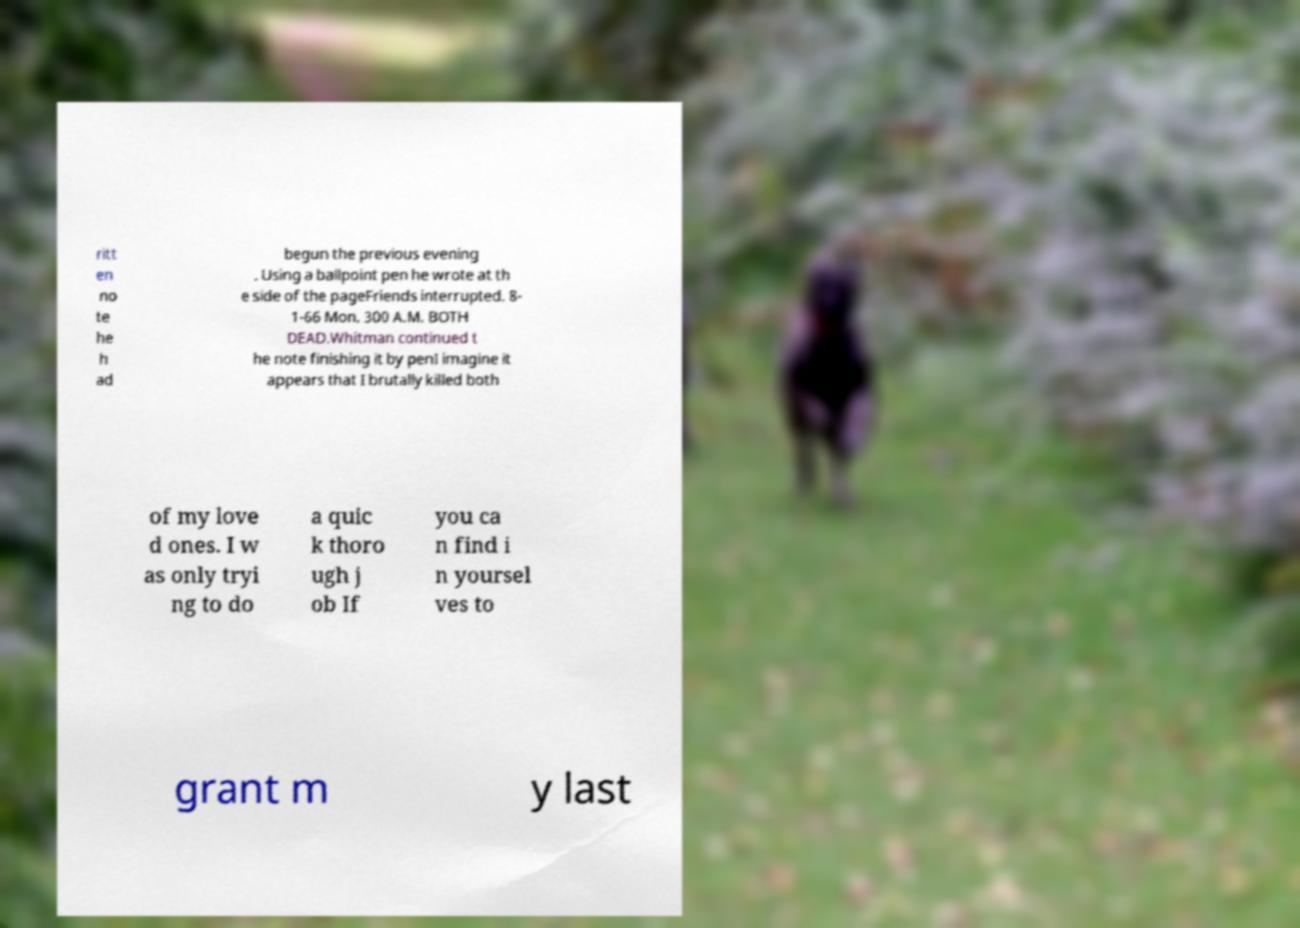Could you extract and type out the text from this image? ritt en no te he h ad begun the previous evening . Using a ballpoint pen he wrote at th e side of the pageFriends interrupted. 8- 1-66 Mon. 300 A.M. BOTH DEAD.Whitman continued t he note finishing it by penI imagine it appears that I brutally killed both of my love d ones. I w as only tryi ng to do a quic k thoro ugh j ob If you ca n find i n yoursel ves to grant m y last 